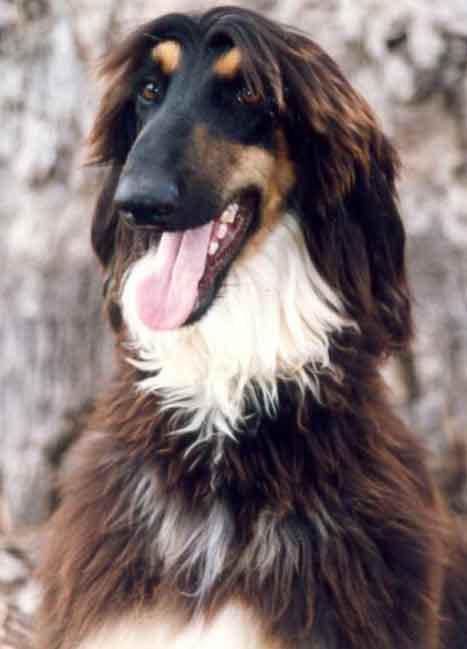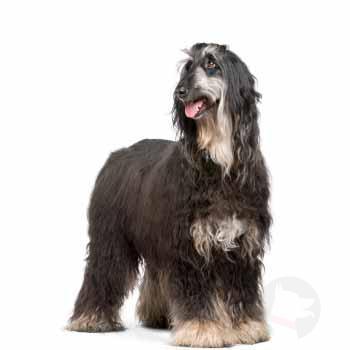The first image is the image on the left, the second image is the image on the right. For the images shown, is this caption "An image shows exactly one dog standing on all fours, and its fur is wavy-textured and dark grayish with paler markings." true? Answer yes or no. Yes. The first image is the image on the left, the second image is the image on the right. Analyze the images presented: Is the assertion "A dog in one of the images is lying down." valid? Answer yes or no. No. 